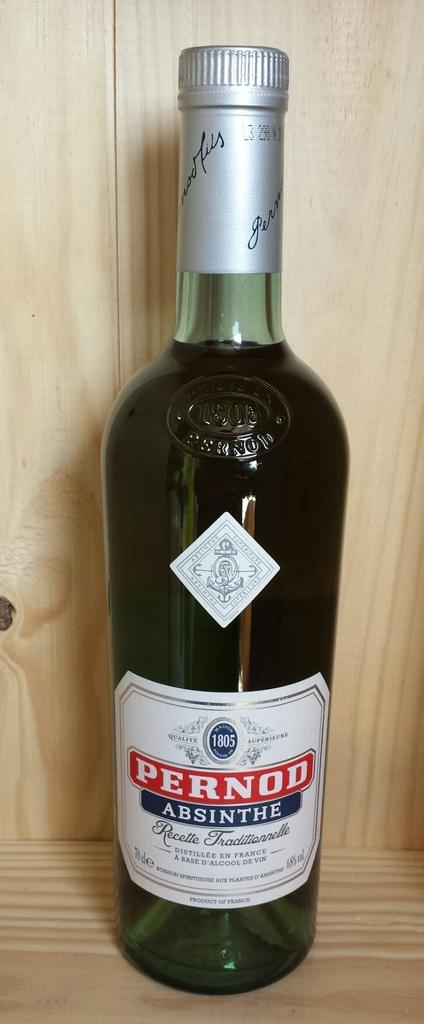<image>
Present a compact description of the photo's key features. A bottle of PERNOD wine sitting on a wooden table 